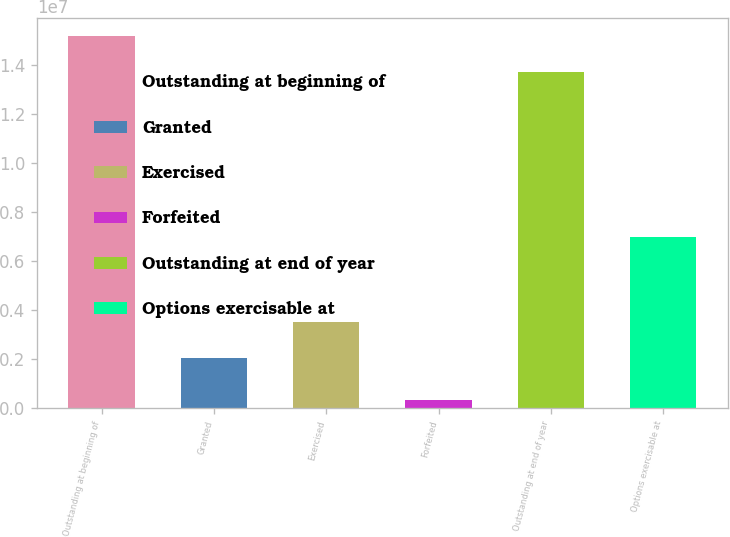Convert chart to OTSL. <chart><loc_0><loc_0><loc_500><loc_500><bar_chart><fcel>Outstanding at beginning of<fcel>Granted<fcel>Exercised<fcel>Forfeited<fcel>Outstanding at end of year<fcel>Options exercisable at<nl><fcel>1.51823e+07<fcel>2.05126e+06<fcel>3.50848e+06<fcel>337259<fcel>1.37251e+07<fcel>7.00194e+06<nl></chart> 